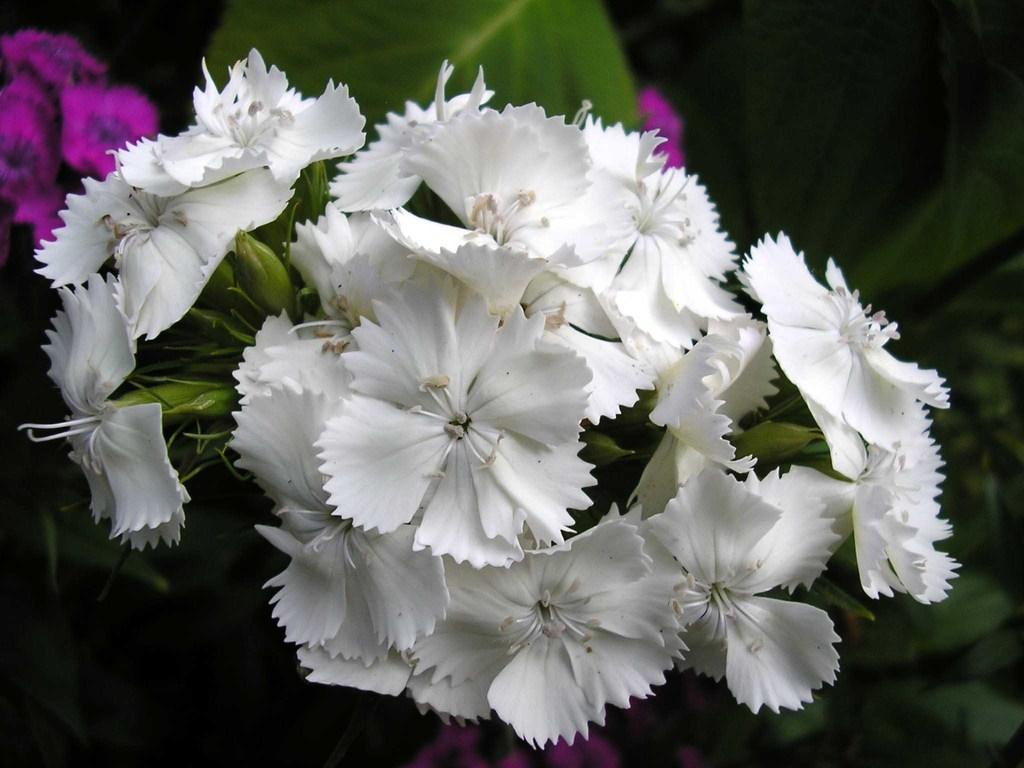What type of plants can be seen in the front of the image? There are flowers in the front of the image. How deep is the ocean in the image? There is no ocean present in the image; it features flowers in the front. What type of clothing is being used to rake the flowers in the image? There is no rake or clothing present in the image; it only features flowers. 